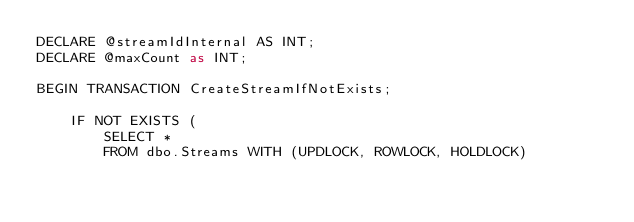<code> <loc_0><loc_0><loc_500><loc_500><_SQL_>DECLARE @streamIdInternal AS INT;
DECLARE @maxCount as INT;

BEGIN TRANSACTION CreateStreamIfNotExists;

    IF NOT EXISTS (
        SELECT *
        FROM dbo.Streams WITH (UPDLOCK, ROWLOCK, HOLDLOCK)</code> 